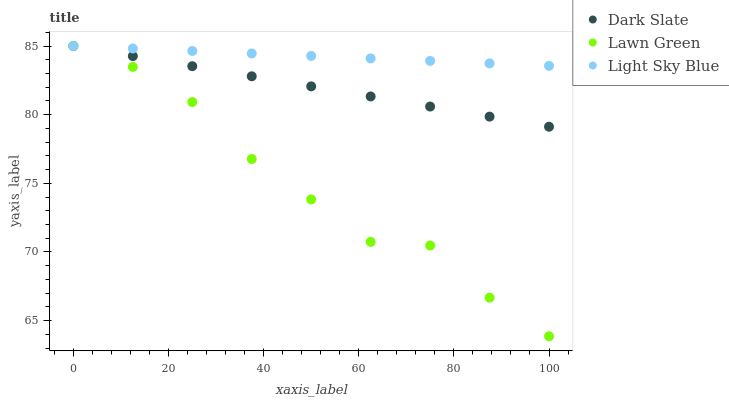Does Lawn Green have the minimum area under the curve?
Answer yes or no. Yes. Does Light Sky Blue have the maximum area under the curve?
Answer yes or no. Yes. Does Light Sky Blue have the minimum area under the curve?
Answer yes or no. No. Does Lawn Green have the maximum area under the curve?
Answer yes or no. No. Is Light Sky Blue the smoothest?
Answer yes or no. Yes. Is Lawn Green the roughest?
Answer yes or no. Yes. Is Lawn Green the smoothest?
Answer yes or no. No. Is Light Sky Blue the roughest?
Answer yes or no. No. Does Lawn Green have the lowest value?
Answer yes or no. Yes. Does Light Sky Blue have the lowest value?
Answer yes or no. No. Does Lawn Green have the highest value?
Answer yes or no. Yes. Does Dark Slate intersect Light Sky Blue?
Answer yes or no. Yes. Is Dark Slate less than Light Sky Blue?
Answer yes or no. No. Is Dark Slate greater than Light Sky Blue?
Answer yes or no. No. 